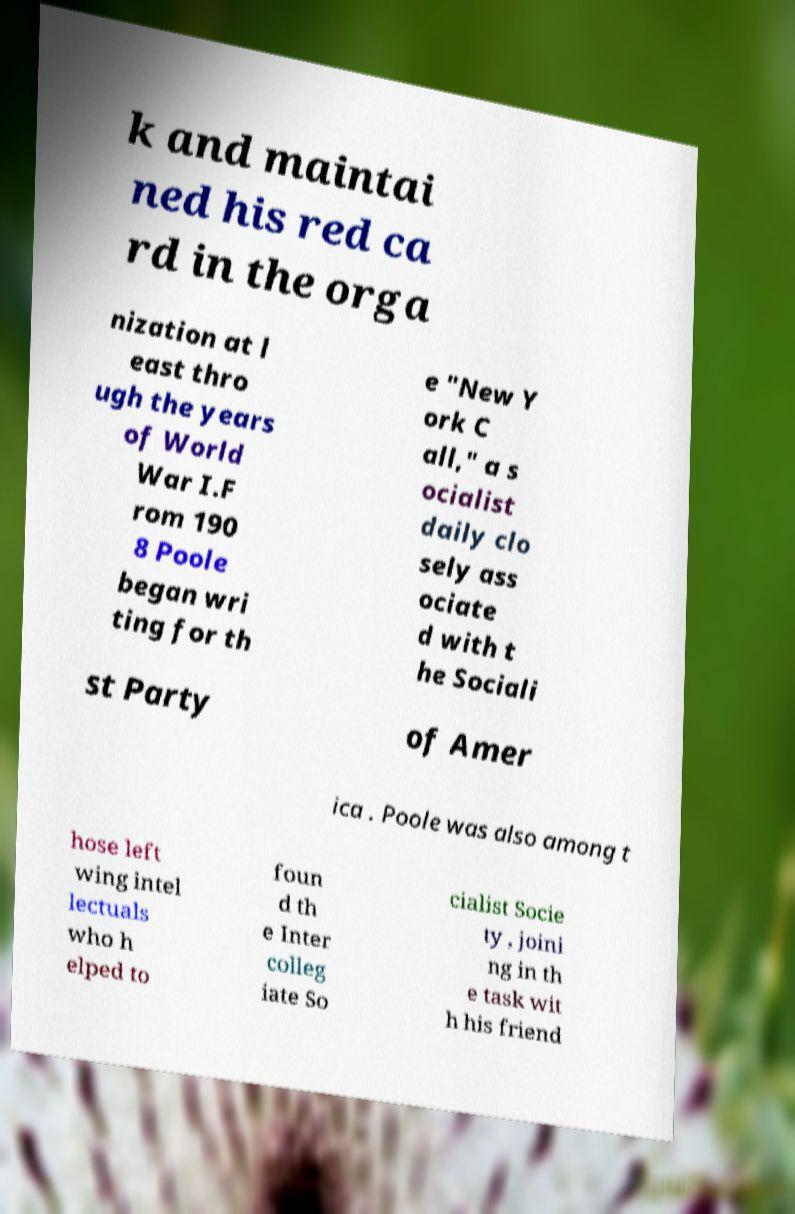Can you read and provide the text displayed in the image?This photo seems to have some interesting text. Can you extract and type it out for me? k and maintai ned his red ca rd in the orga nization at l east thro ugh the years of World War I.F rom 190 8 Poole began wri ting for th e "New Y ork C all," a s ocialist daily clo sely ass ociate d with t he Sociali st Party of Amer ica . Poole was also among t hose left wing intel lectuals who h elped to foun d th e Inter colleg iate So cialist Socie ty , joini ng in th e task wit h his friend 